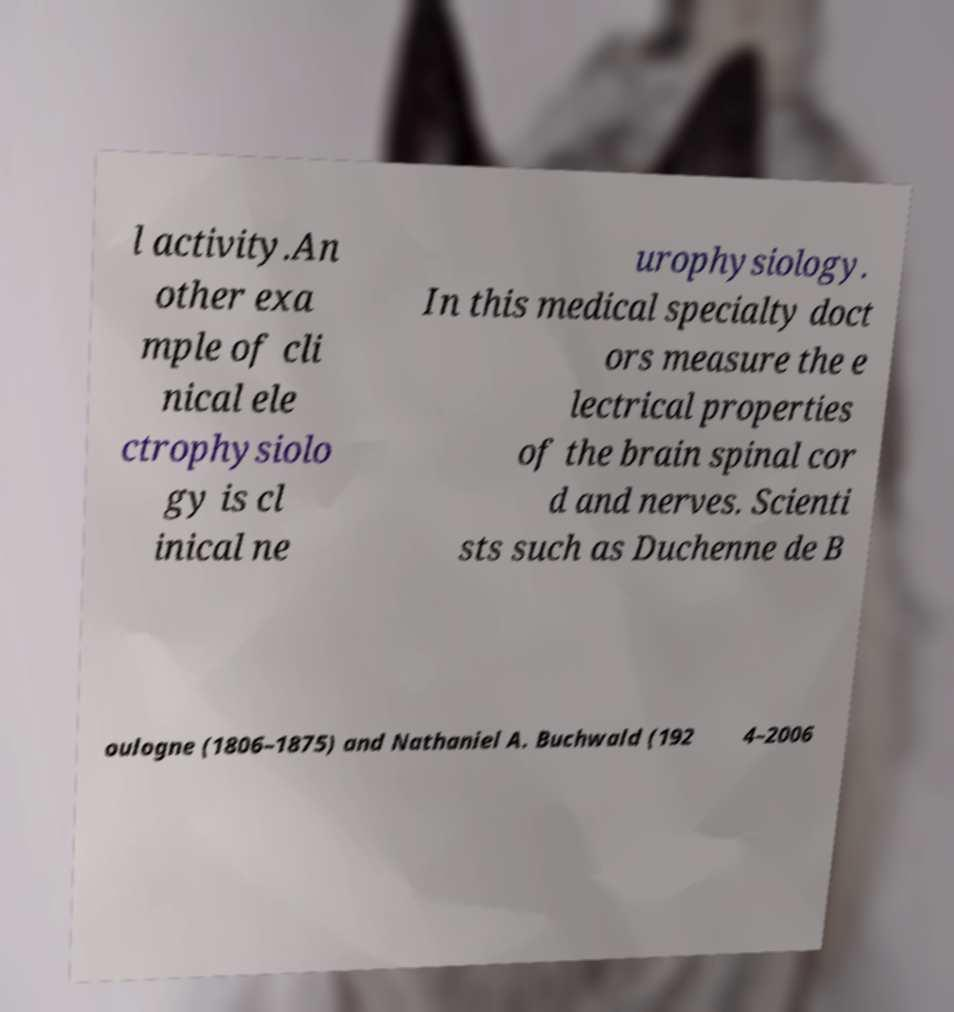Please read and relay the text visible in this image. What does it say? l activity.An other exa mple of cli nical ele ctrophysiolo gy is cl inical ne urophysiology. In this medical specialty doct ors measure the e lectrical properties of the brain spinal cor d and nerves. Scienti sts such as Duchenne de B oulogne (1806–1875) and Nathaniel A. Buchwald (192 4–2006 